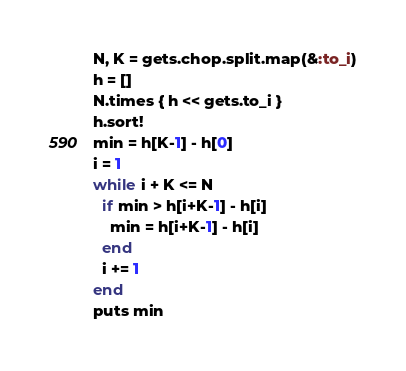Convert code to text. <code><loc_0><loc_0><loc_500><loc_500><_Ruby_>N, K = gets.chop.split.map(&:to_i)
h = []
N.times { h << gets.to_i }
h.sort!
min = h[K-1] - h[0]
i = 1
while i + K <= N
  if min > h[i+K-1] - h[i]
    min = h[i+K-1] - h[i]
  end
  i += 1
end
puts min
</code> 